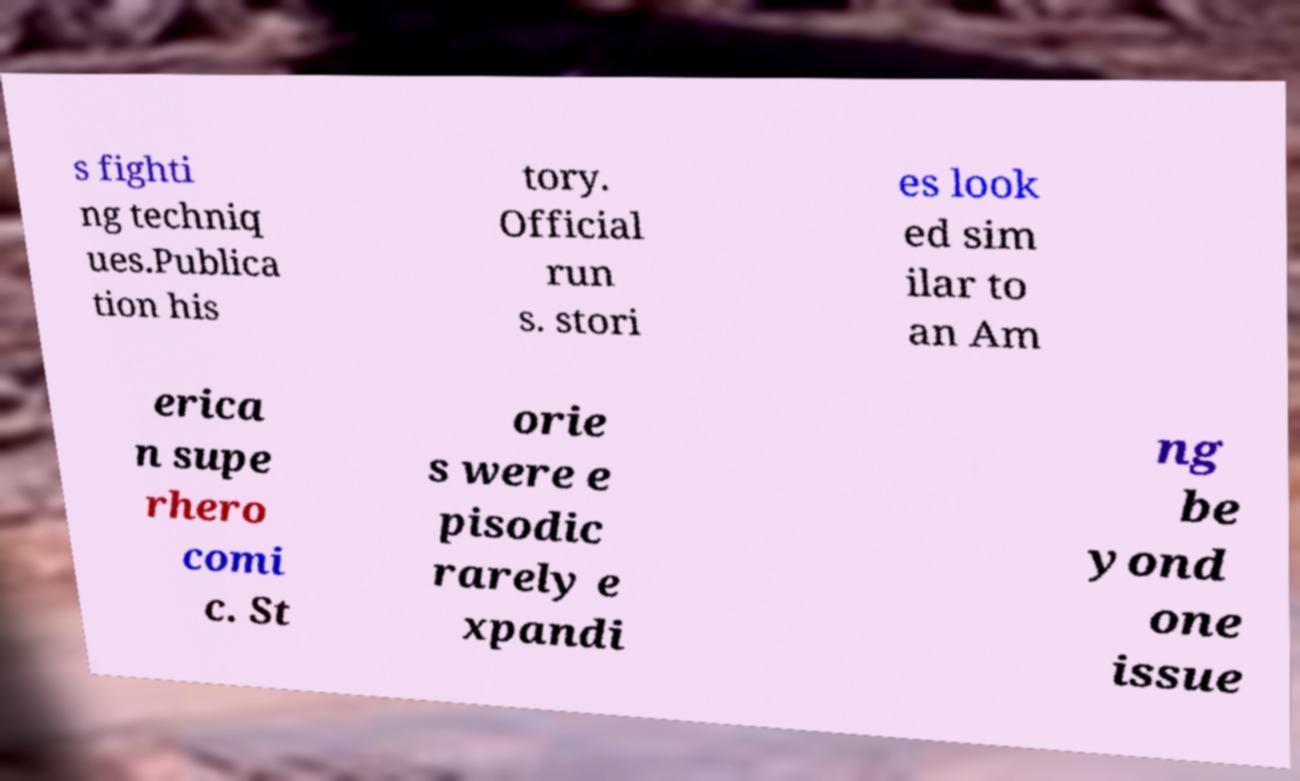I need the written content from this picture converted into text. Can you do that? s fighti ng techniq ues.Publica tion his tory. Official run s. stori es look ed sim ilar to an Am erica n supe rhero comi c. St orie s were e pisodic rarely e xpandi ng be yond one issue 